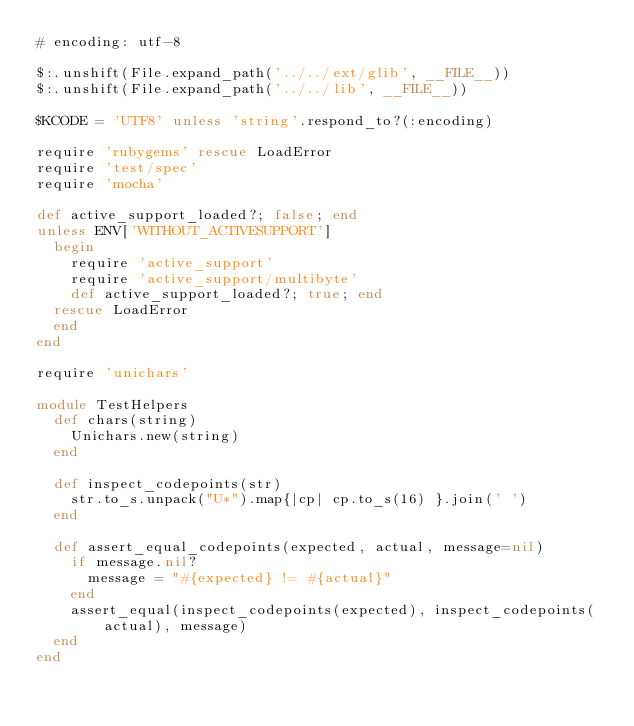<code> <loc_0><loc_0><loc_500><loc_500><_Ruby_># encoding: utf-8

$:.unshift(File.expand_path('../../ext/glib', __FILE__))
$:.unshift(File.expand_path('../../lib', __FILE__))

$KCODE = 'UTF8' unless 'string'.respond_to?(:encoding)

require 'rubygems' rescue LoadError
require 'test/spec'
require 'mocha'

def active_support_loaded?; false; end
unless ENV['WITHOUT_ACTIVESUPPORT']
  begin
    require 'active_support'
    require 'active_support/multibyte'
    def active_support_loaded?; true; end
  rescue LoadError
  end
end

require 'unichars'

module TestHelpers
  def chars(string)
    Unichars.new(string)
  end
  
  def inspect_codepoints(str)
    str.to_s.unpack("U*").map{|cp| cp.to_s(16) }.join(' ')
  end
  
  def assert_equal_codepoints(expected, actual, message=nil)
    if message.nil?
      message = "#{expected} != #{actual}"
    end
    assert_equal(inspect_codepoints(expected), inspect_codepoints(actual), message)
  end
end
</code> 